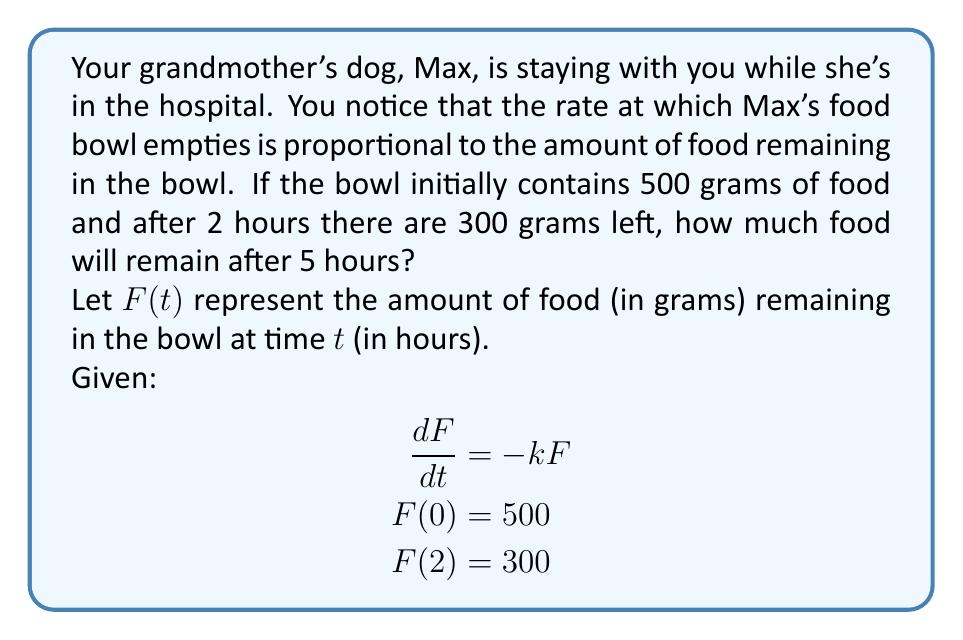Solve this math problem. 1) First, we need to solve the differential equation:
   $$\frac{dF}{dt} = -kF$$

2) Separating variables:
   $$\frac{dF}{F} = -k dt$$

3) Integrating both sides:
   $$\int \frac{dF}{F} = -k \int dt$$
   $$\ln|F| = -kt + C$$

4) Solving for $F$:
   $$F(t) = Ae^{-kt}$$
   where $A$ is a constant.

5) Using the initial condition $F(0) = 500$:
   $$500 = Ae^{-k(0)} = A$$

6) So our solution is:
   $$F(t) = 500e^{-kt}$$

7) Now we can use $F(2) = 300$ to find $k$:
   $$300 = 500e^{-2k}$$
   $$\frac{3}{5} = e^{-2k}$$
   $$\ln(\frac{3}{5}) = -2k$$
   $$k = -\frac{1}{2}\ln(\frac{3}{5}) \approx 0.2554$$

8) Now we have our complete solution:
   $$F(t) = 500e^{-0.2554t}$$

9) To find the amount of food after 5 hours, we evaluate $F(5)$:
   $$F(5) = 500e^{-0.2554(5)} \approx 145.4$$

Therefore, after 5 hours, approximately 145.4 grams of food will remain in Max's bowl.
Answer: 145.4 grams 